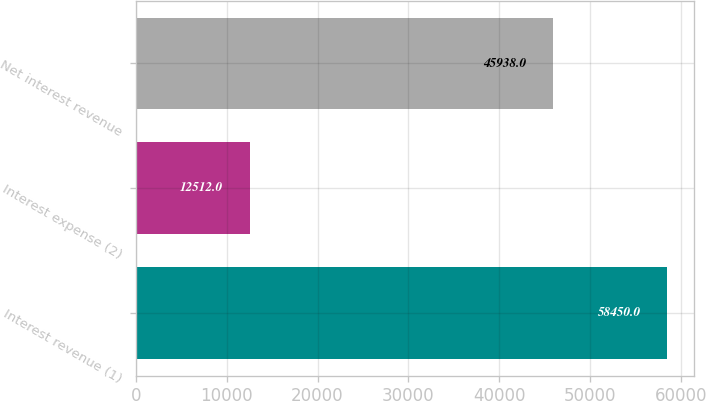Convert chart to OTSL. <chart><loc_0><loc_0><loc_500><loc_500><bar_chart><fcel>Interest revenue (1)<fcel>Interest expense (2)<fcel>Net interest revenue<nl><fcel>58450<fcel>12512<fcel>45938<nl></chart> 